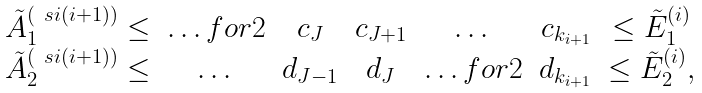Convert formula to latex. <formula><loc_0><loc_0><loc_500><loc_500>\begin{array} { r c c c c c c l } \tilde { A } ^ { ( \ s i ( i + 1 ) ) } _ { 1 } \leq & \hdots f o r 2 & c _ { J } & c _ { J + 1 } & \dots & c _ { k _ { i + 1 } } & \leq \tilde { E } ^ { ( i ) } _ { 1 } \\ \tilde { A } ^ { ( \ s i ( i + 1 ) ) } _ { 2 } \leq & \dots & d _ { J - 1 } & d _ { J } & \hdots f o r 2 & d _ { k _ { i + 1 } } & \leq \tilde { E } ^ { ( i ) } _ { 2 } , \end{array}</formula> 